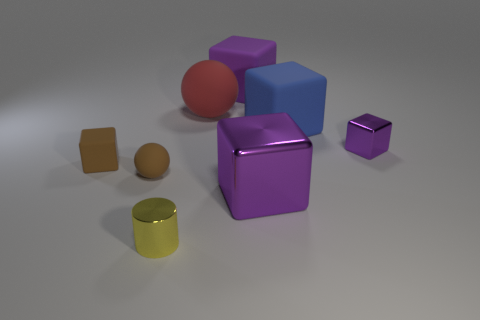Subtract all purple cylinders. How many purple blocks are left? 3 Subtract all blue blocks. How many blocks are left? 4 Subtract all tiny blocks. How many blocks are left? 3 Subtract 1 blocks. How many blocks are left? 4 Add 2 tiny red metal cylinders. How many objects exist? 10 Subtract all brown blocks. Subtract all cyan cylinders. How many blocks are left? 4 Subtract all blocks. How many objects are left? 3 Add 5 metallic blocks. How many metallic blocks exist? 7 Subtract 0 blue cylinders. How many objects are left? 8 Subtract all big purple cubes. Subtract all brown blocks. How many objects are left? 5 